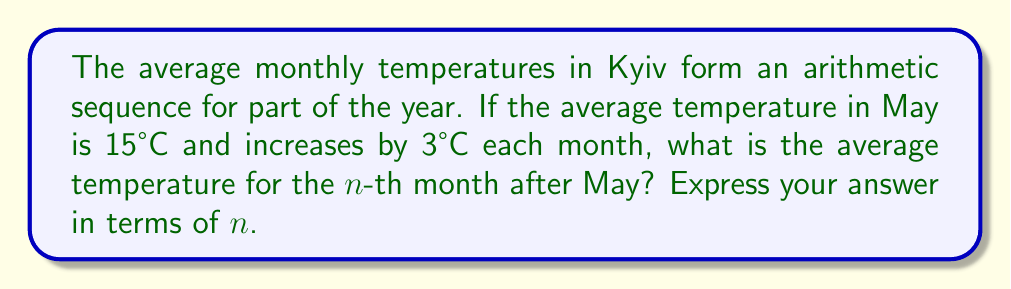Solve this math problem. Let's approach this step-by-step:

1) In an arithmetic sequence, the difference between each consecutive term is constant. Here, the common difference is 3°C.

2) We are given that the first term (May) is 15°C. Let's call this $a_1$.

3) The general formula for the $n$-th term of an arithmetic sequence is:

   $a_n = a_1 + (n-1)d$

   Where:
   $a_n$ is the $n$-th term
   $a_1$ is the first term
   $n$ is the position of the term
   $d$ is the common difference

4) Substituting our known values:
   $a_1 = 15$ (May temperature)
   $d = 3$ (temperature increase per month)

5) Therefore, our formula becomes:

   $a_n = 15 + (n-1)3$

6) Simplifying:
   $a_n = 15 + 3n - 3$
   $a_n = 3n + 12$

This formula gives the temperature for the $n$-th month after May.
Answer: $a_n = 3n + 12$ 